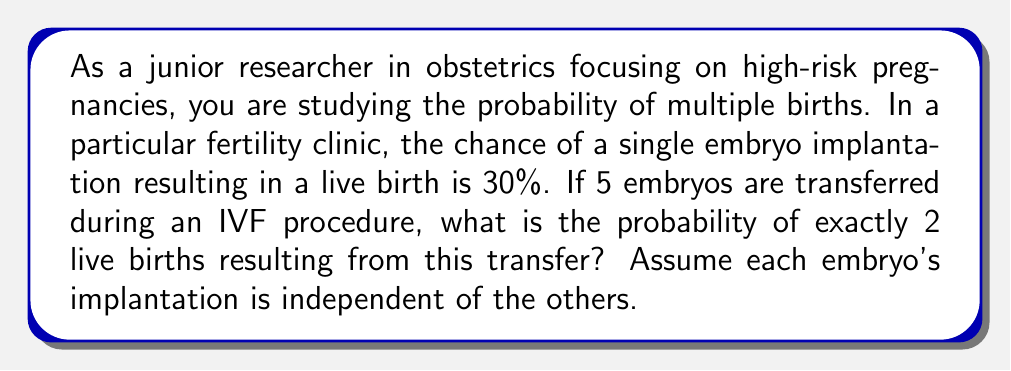Solve this math problem. To solve this problem, we can use the concept of binomial probability. This scenario fits the binomial distribution because:

1. There are a fixed number of trials (5 embryo transfers)
2. Each trial has two possible outcomes (successful live birth or not)
3. The probability of success is the same for each trial (30%)
4. The trials are independent

The binomial probability formula is:

$$ P(X = k) = \binom{n}{k} p^k (1-p)^{n-k} $$

Where:
- $n$ is the number of trials (5 embryos)
- $k$ is the number of successes (2 live births)
- $p$ is the probability of success on each trial (30% or 0.3)

Let's substitute these values:

$$ P(X = 2) = \binom{5}{2} (0.3)^2 (1-0.3)^{5-2} $$

Now, let's calculate step by step:

1. Calculate $\binom{5}{2}$:
   $\binom{5}{2} = \frac{5!}{2!(5-2)!} = \frac{5 \cdot 4}{2 \cdot 1} = 10$

2. Calculate $(0.3)^2$:
   $(0.3)^2 = 0.09$

3. Calculate $(1-0.3)^{5-2}$:
   $(0.7)^3 = 0.343$

4. Multiply all parts together:
   $10 \cdot 0.09 \cdot 0.343 = 0.30870$

Therefore, the probability of exactly 2 live births from 5 embryo transfers is approximately 0.3087 or 30.87%.
Answer: The probability of exactly 2 live births resulting from the transfer of 5 embryos is approximately 0.3087 or 30.87%. 